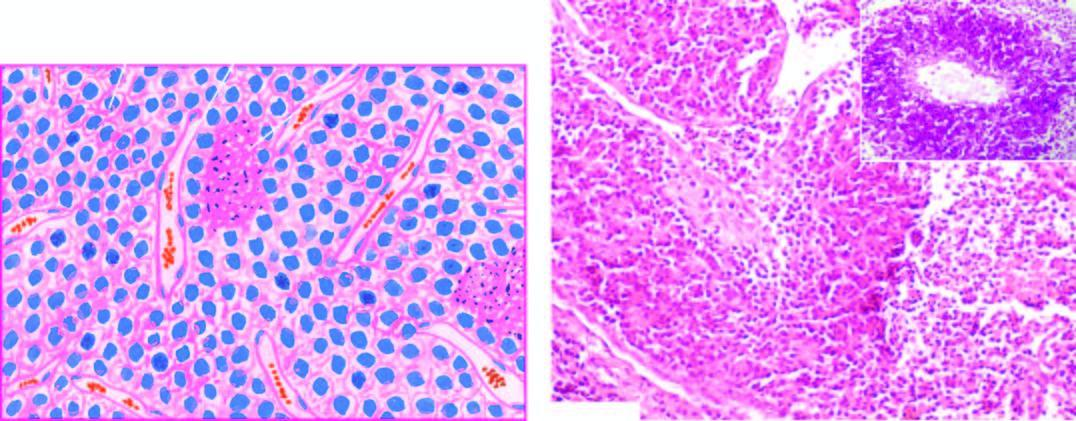does the cytoplasm show pas positive tumour cells in perivascular location?
Answer the question using a single word or phrase. No 